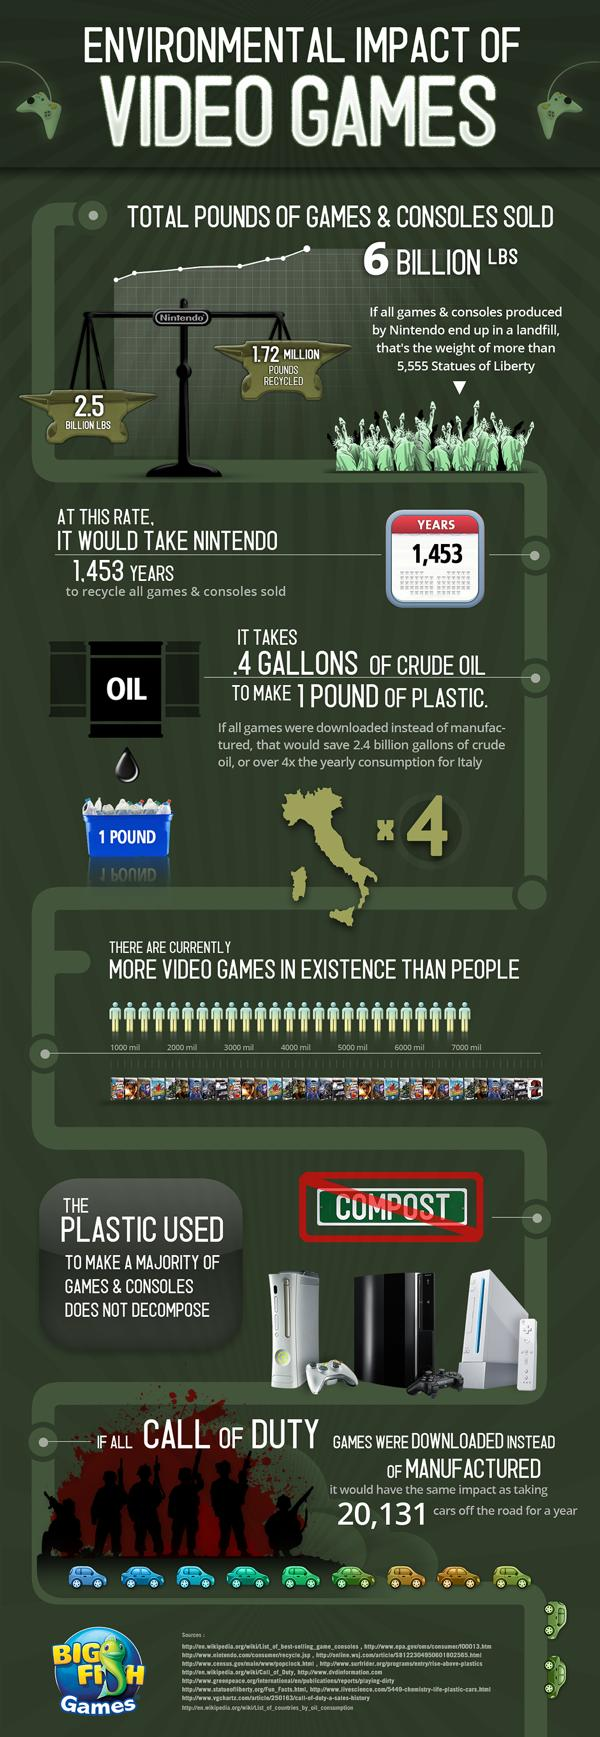Point out several critical features in this image. The world's population is approximately 7 billion people. 